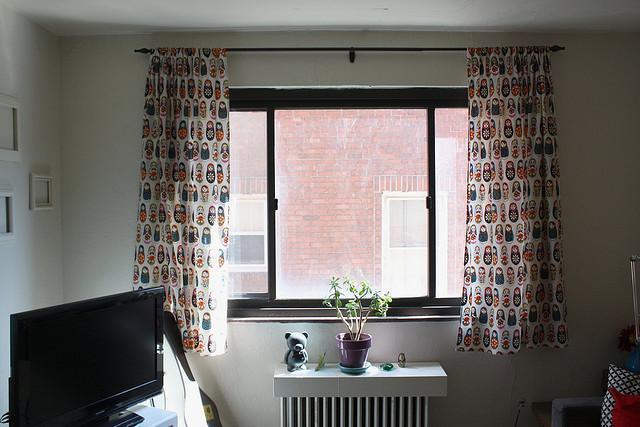How many people are riding bikes?
Give a very brief answer. 0. 